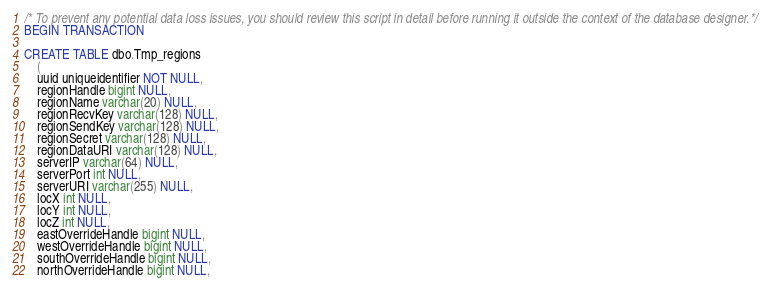<code> <loc_0><loc_0><loc_500><loc_500><_SQL_>/* To prevent any potential data loss issues, you should review this script in detail before running it outside the context of the database designer.*/
BEGIN TRANSACTION

CREATE TABLE dbo.Tmp_regions
	(
	uuid uniqueidentifier NOT NULL,
	regionHandle bigint NULL,
	regionName varchar(20) NULL,
	regionRecvKey varchar(128) NULL,
	regionSendKey varchar(128) NULL,
	regionSecret varchar(128) NULL,
	regionDataURI varchar(128) NULL,
	serverIP varchar(64) NULL,
	serverPort int NULL,
	serverURI varchar(255) NULL,
	locX int NULL,
	locY int NULL,
	locZ int NULL,
	eastOverrideHandle bigint NULL,
	westOverrideHandle bigint NULL,
	southOverrideHandle bigint NULL,
	northOverrideHandle bigint NULL,</code> 